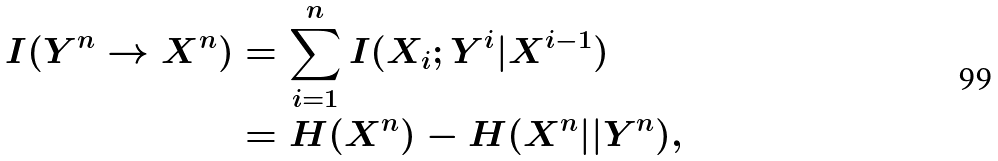Convert formula to latex. <formula><loc_0><loc_0><loc_500><loc_500>I ( Y ^ { n } \to X ^ { n } ) & = \sum _ { i = 1 } ^ { n } I ( X _ { i } ; Y ^ { i } | X ^ { i - 1 } ) \\ & = H ( X ^ { n } ) - H ( X ^ { n } | | Y ^ { n } ) ,</formula> 